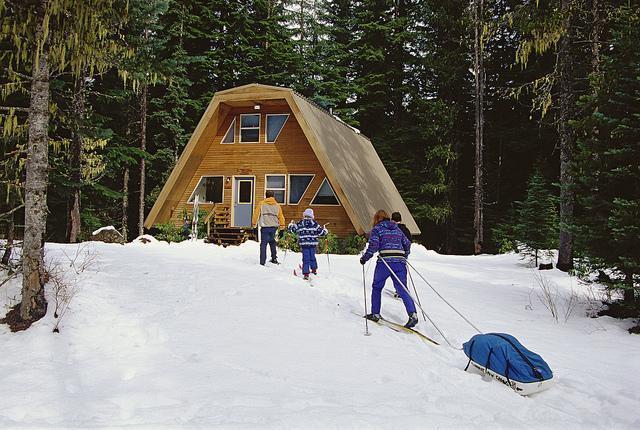How many cars are in this photo?
Give a very brief answer. 0. How many people are there?
Give a very brief answer. 1. 